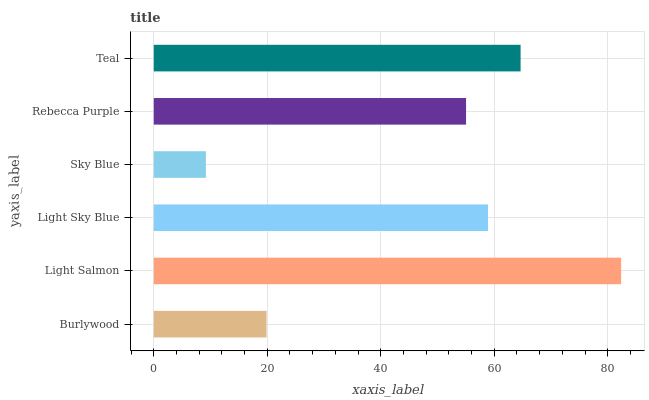Is Sky Blue the minimum?
Answer yes or no. Yes. Is Light Salmon the maximum?
Answer yes or no. Yes. Is Light Sky Blue the minimum?
Answer yes or no. No. Is Light Sky Blue the maximum?
Answer yes or no. No. Is Light Salmon greater than Light Sky Blue?
Answer yes or no. Yes. Is Light Sky Blue less than Light Salmon?
Answer yes or no. Yes. Is Light Sky Blue greater than Light Salmon?
Answer yes or no. No. Is Light Salmon less than Light Sky Blue?
Answer yes or no. No. Is Light Sky Blue the high median?
Answer yes or no. Yes. Is Rebecca Purple the low median?
Answer yes or no. Yes. Is Teal the high median?
Answer yes or no. No. Is Burlywood the low median?
Answer yes or no. No. 